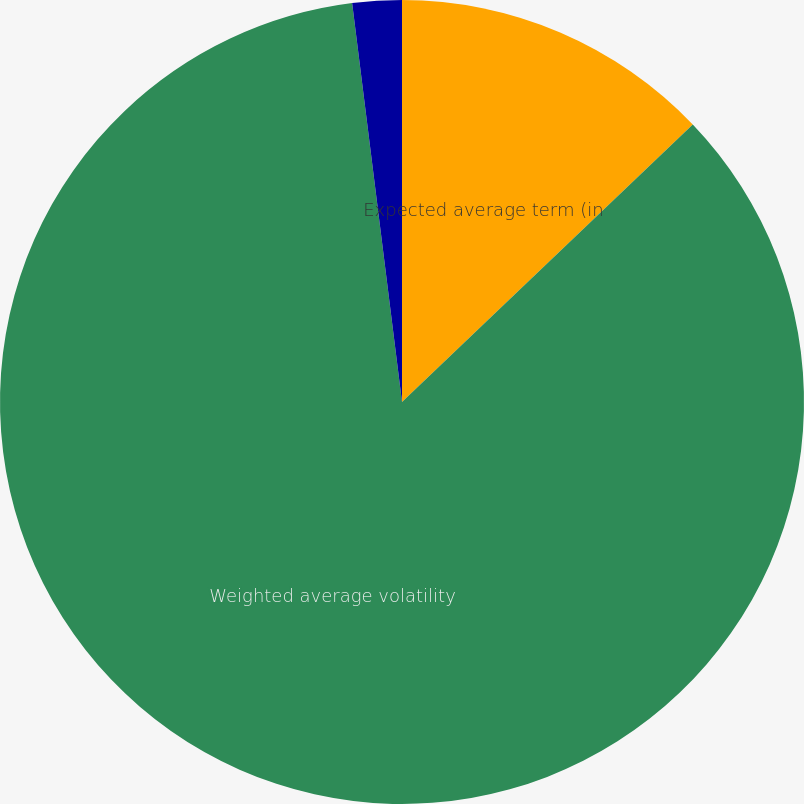<chart> <loc_0><loc_0><loc_500><loc_500><pie_chart><fcel>Expected average term (in<fcel>Weighted average volatility<fcel>Expected dividend yield<nl><fcel>12.87%<fcel>85.15%<fcel>1.98%<nl></chart> 